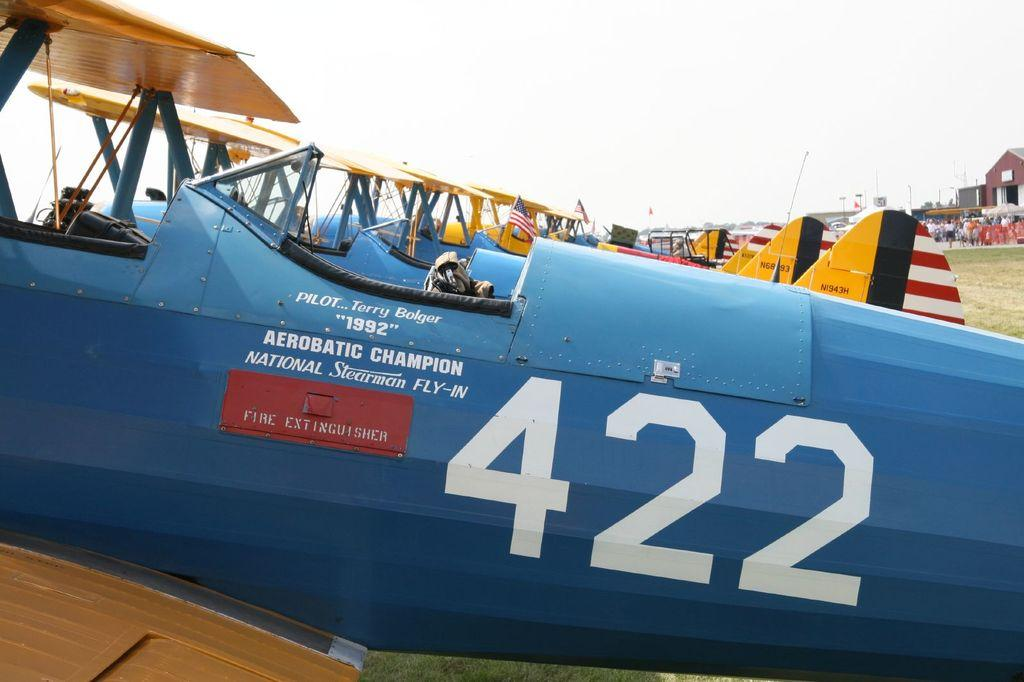<image>
Render a clear and concise summary of the photo. A row of blue biplanes are parked in a field with the number 422 on the side. 